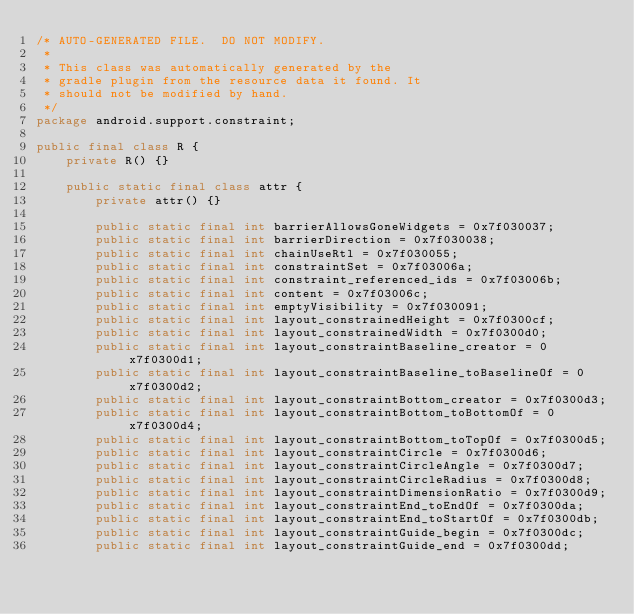Convert code to text. <code><loc_0><loc_0><loc_500><loc_500><_Java_>/* AUTO-GENERATED FILE.  DO NOT MODIFY.
 *
 * This class was automatically generated by the
 * gradle plugin from the resource data it found. It
 * should not be modified by hand.
 */
package android.support.constraint;

public final class R {
    private R() {}

    public static final class attr {
        private attr() {}

        public static final int barrierAllowsGoneWidgets = 0x7f030037;
        public static final int barrierDirection = 0x7f030038;
        public static final int chainUseRtl = 0x7f030055;
        public static final int constraintSet = 0x7f03006a;
        public static final int constraint_referenced_ids = 0x7f03006b;
        public static final int content = 0x7f03006c;
        public static final int emptyVisibility = 0x7f030091;
        public static final int layout_constrainedHeight = 0x7f0300cf;
        public static final int layout_constrainedWidth = 0x7f0300d0;
        public static final int layout_constraintBaseline_creator = 0x7f0300d1;
        public static final int layout_constraintBaseline_toBaselineOf = 0x7f0300d2;
        public static final int layout_constraintBottom_creator = 0x7f0300d3;
        public static final int layout_constraintBottom_toBottomOf = 0x7f0300d4;
        public static final int layout_constraintBottom_toTopOf = 0x7f0300d5;
        public static final int layout_constraintCircle = 0x7f0300d6;
        public static final int layout_constraintCircleAngle = 0x7f0300d7;
        public static final int layout_constraintCircleRadius = 0x7f0300d8;
        public static final int layout_constraintDimensionRatio = 0x7f0300d9;
        public static final int layout_constraintEnd_toEndOf = 0x7f0300da;
        public static final int layout_constraintEnd_toStartOf = 0x7f0300db;
        public static final int layout_constraintGuide_begin = 0x7f0300dc;
        public static final int layout_constraintGuide_end = 0x7f0300dd;</code> 